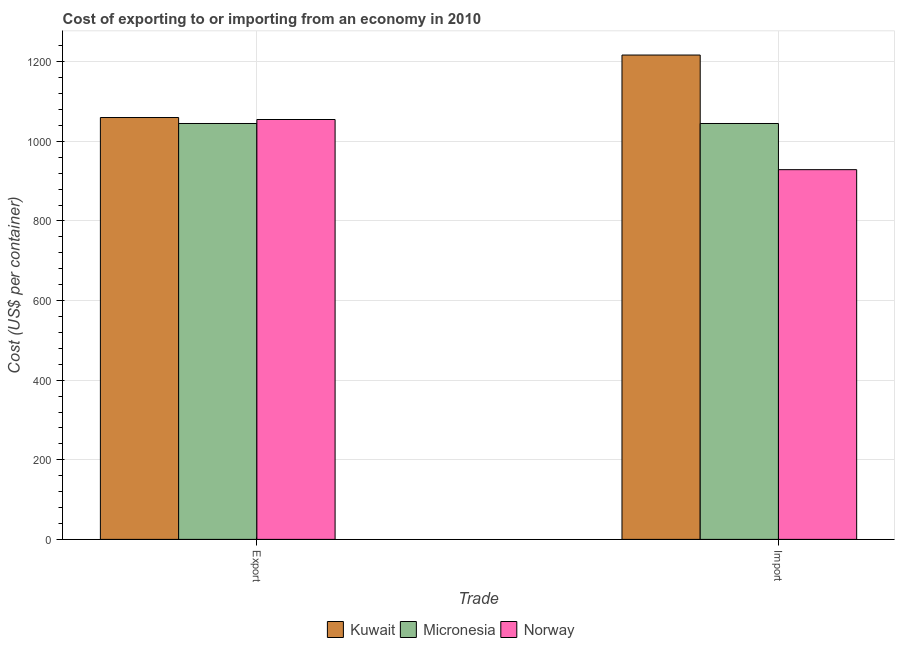How many different coloured bars are there?
Offer a very short reply. 3. How many groups of bars are there?
Your response must be concise. 2. Are the number of bars per tick equal to the number of legend labels?
Your response must be concise. Yes. Are the number of bars on each tick of the X-axis equal?
Provide a succinct answer. Yes. What is the label of the 1st group of bars from the left?
Your answer should be very brief. Export. What is the export cost in Kuwait?
Offer a terse response. 1060. Across all countries, what is the maximum import cost?
Keep it short and to the point. 1217. Across all countries, what is the minimum import cost?
Ensure brevity in your answer.  929. In which country was the export cost maximum?
Your response must be concise. Kuwait. In which country was the export cost minimum?
Offer a terse response. Micronesia. What is the total export cost in the graph?
Offer a very short reply. 3160. What is the difference between the import cost in Kuwait and that in Norway?
Give a very brief answer. 288. What is the difference between the export cost in Micronesia and the import cost in Norway?
Make the answer very short. 116. What is the average import cost per country?
Your response must be concise. 1063.67. What is the difference between the export cost and import cost in Kuwait?
Offer a very short reply. -157. What is the ratio of the import cost in Kuwait to that in Micronesia?
Ensure brevity in your answer.  1.16. Is the export cost in Norway less than that in Kuwait?
Your answer should be compact. Yes. What does the 3rd bar from the left in Import represents?
Your response must be concise. Norway. What does the 2nd bar from the right in Export represents?
Your answer should be very brief. Micronesia. How many bars are there?
Provide a succinct answer. 6. Are all the bars in the graph horizontal?
Offer a very short reply. No. What is the difference between two consecutive major ticks on the Y-axis?
Offer a terse response. 200. Are the values on the major ticks of Y-axis written in scientific E-notation?
Ensure brevity in your answer.  No. How are the legend labels stacked?
Provide a succinct answer. Horizontal. What is the title of the graph?
Ensure brevity in your answer.  Cost of exporting to or importing from an economy in 2010. What is the label or title of the X-axis?
Your answer should be very brief. Trade. What is the label or title of the Y-axis?
Your response must be concise. Cost (US$ per container). What is the Cost (US$ per container) in Kuwait in Export?
Provide a succinct answer. 1060. What is the Cost (US$ per container) of Micronesia in Export?
Offer a very short reply. 1045. What is the Cost (US$ per container) of Norway in Export?
Provide a short and direct response. 1055. What is the Cost (US$ per container) of Kuwait in Import?
Provide a short and direct response. 1217. What is the Cost (US$ per container) of Micronesia in Import?
Offer a very short reply. 1045. What is the Cost (US$ per container) of Norway in Import?
Your answer should be compact. 929. Across all Trade, what is the maximum Cost (US$ per container) of Kuwait?
Your answer should be very brief. 1217. Across all Trade, what is the maximum Cost (US$ per container) in Micronesia?
Your response must be concise. 1045. Across all Trade, what is the maximum Cost (US$ per container) of Norway?
Provide a short and direct response. 1055. Across all Trade, what is the minimum Cost (US$ per container) of Kuwait?
Your answer should be compact. 1060. Across all Trade, what is the minimum Cost (US$ per container) in Micronesia?
Offer a terse response. 1045. Across all Trade, what is the minimum Cost (US$ per container) in Norway?
Your response must be concise. 929. What is the total Cost (US$ per container) of Kuwait in the graph?
Ensure brevity in your answer.  2277. What is the total Cost (US$ per container) of Micronesia in the graph?
Your response must be concise. 2090. What is the total Cost (US$ per container) of Norway in the graph?
Provide a succinct answer. 1984. What is the difference between the Cost (US$ per container) of Kuwait in Export and that in Import?
Your answer should be compact. -157. What is the difference between the Cost (US$ per container) in Micronesia in Export and that in Import?
Keep it short and to the point. 0. What is the difference between the Cost (US$ per container) in Norway in Export and that in Import?
Keep it short and to the point. 126. What is the difference between the Cost (US$ per container) of Kuwait in Export and the Cost (US$ per container) of Norway in Import?
Ensure brevity in your answer.  131. What is the difference between the Cost (US$ per container) of Micronesia in Export and the Cost (US$ per container) of Norway in Import?
Offer a very short reply. 116. What is the average Cost (US$ per container) of Kuwait per Trade?
Give a very brief answer. 1138.5. What is the average Cost (US$ per container) in Micronesia per Trade?
Your answer should be very brief. 1045. What is the average Cost (US$ per container) in Norway per Trade?
Offer a very short reply. 992. What is the difference between the Cost (US$ per container) of Kuwait and Cost (US$ per container) of Norway in Export?
Give a very brief answer. 5. What is the difference between the Cost (US$ per container) of Micronesia and Cost (US$ per container) of Norway in Export?
Your answer should be very brief. -10. What is the difference between the Cost (US$ per container) in Kuwait and Cost (US$ per container) in Micronesia in Import?
Give a very brief answer. 172. What is the difference between the Cost (US$ per container) in Kuwait and Cost (US$ per container) in Norway in Import?
Keep it short and to the point. 288. What is the difference between the Cost (US$ per container) of Micronesia and Cost (US$ per container) of Norway in Import?
Offer a very short reply. 116. What is the ratio of the Cost (US$ per container) in Kuwait in Export to that in Import?
Your response must be concise. 0.87. What is the ratio of the Cost (US$ per container) in Norway in Export to that in Import?
Your answer should be very brief. 1.14. What is the difference between the highest and the second highest Cost (US$ per container) of Kuwait?
Provide a short and direct response. 157. What is the difference between the highest and the second highest Cost (US$ per container) in Micronesia?
Ensure brevity in your answer.  0. What is the difference between the highest and the second highest Cost (US$ per container) in Norway?
Your answer should be compact. 126. What is the difference between the highest and the lowest Cost (US$ per container) of Kuwait?
Your response must be concise. 157. What is the difference between the highest and the lowest Cost (US$ per container) of Norway?
Your response must be concise. 126. 